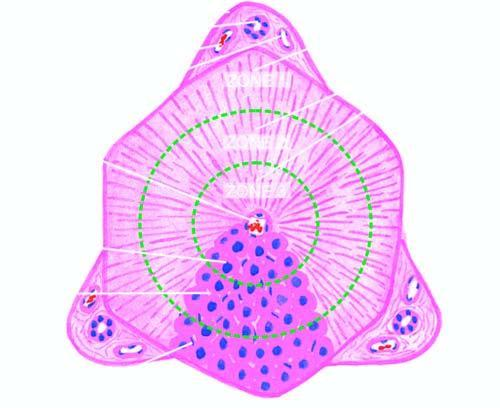s the number of layers termed the classical lobule?
Answer the question using a single word or phrase. No 